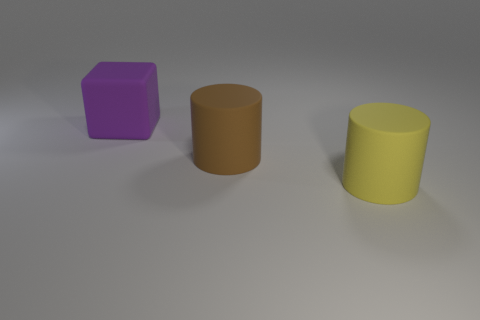Are there the same number of matte cylinders that are on the left side of the large yellow rubber cylinder and big brown matte cylinders?
Offer a very short reply. Yes. There is a matte thing behind the brown thing; is it the same size as the yellow matte object?
Offer a very short reply. Yes. There is a purple cube; how many large matte objects are in front of it?
Offer a terse response. 2. What number of tiny things are either cubes or gray rubber cylinders?
Provide a succinct answer. 0. What is the shape of the yellow thing?
Offer a terse response. Cylinder. Is there any other thing that is the same shape as the purple object?
Make the answer very short. No. Is the number of big matte blocks that are right of the yellow cylinder less than the number of large brown matte cylinders?
Your response must be concise. Yes. Do the cylinder that is behind the yellow thing and the cube have the same color?
Your answer should be compact. No. How many rubber objects are either big objects or large cylinders?
Provide a succinct answer. 3. The large block that is the same material as the yellow cylinder is what color?
Give a very brief answer. Purple. 